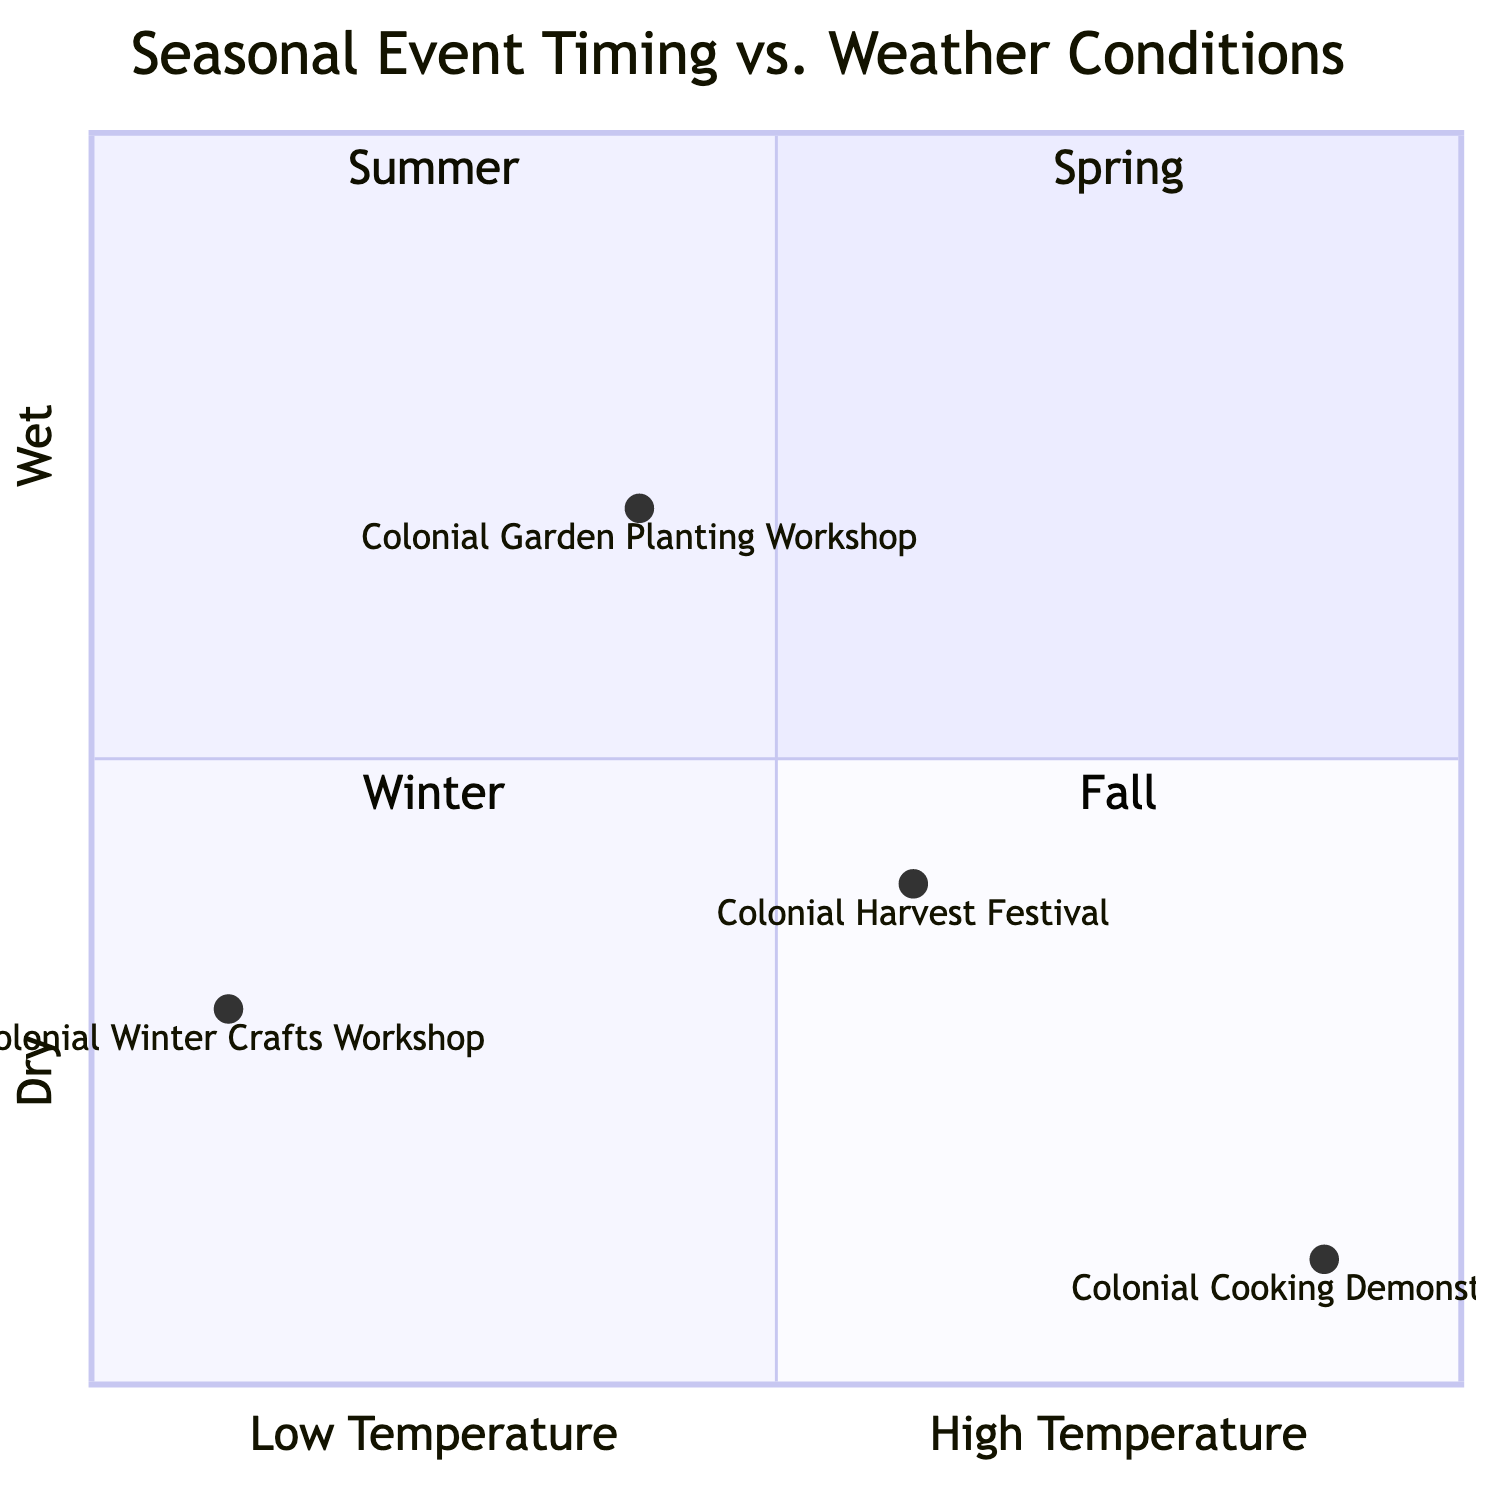What is the event associated with Spring? In the diagram, Spring is represented in quadrant 1, and the event listed there is the "Colonial Garden Planting Workshop."
Answer: Colonial Garden Planting Workshop What is the ideal weather condition for the Colonial Cooking Demonstration? The Colonial Cooking Demonstration is in quadrant 2, and its ideal weather condition is "Warm to hot, dry" as indicated in the diagram.
Answer: Warm to hot, dry How many events are represented in the diagram? There are four events listed in the diagram: one for each season: Spring, Summer, Fall, and Winter. Counting these, the total number of events is four.
Answer: 4 What season is represented in quadrant 4? Quadrant 4 is located in the lower right part of the diagram, and it is where Fall is represented.
Answer: Fall Which event occurs in the Winter season? The event that takes place in the Winter season is noted in quadrant 3, and it is the "Colonial Winter Crafts Workshop."
Answer: Colonial Winter Crafts Workshop Which event has the highest ideal temperature in the diagram? Among the events, the one with the highest ideal temperature is the "Colonial Cooking Demonstration," which is found in quadrant 2 where it indicates warm to hot weather.
Answer: Colonial Cooking Demonstration What is the time frame for the Colonial Harvest Festival? The time frame for the event situated in Fall, the "Colonial Harvest Festival," is noted as "September - October" in the diagram.
Answer: September - October What quadrant corresponds to the event featuring winter crafts? The event featuring winter crafts, "Colonial Winter Crafts Workshop," is in quadrant 3, which corresponds to the winter season.
Answer: Quadrant 3 What is the ideal weather condition for the Colonial Harvest Festival? The ideal weather condition for the event in Fall, the "Colonial Harvest Festival," is listed in the diagram as "Cool temperatures, partly cloudy."
Answer: Cool temperatures, partly cloudy 